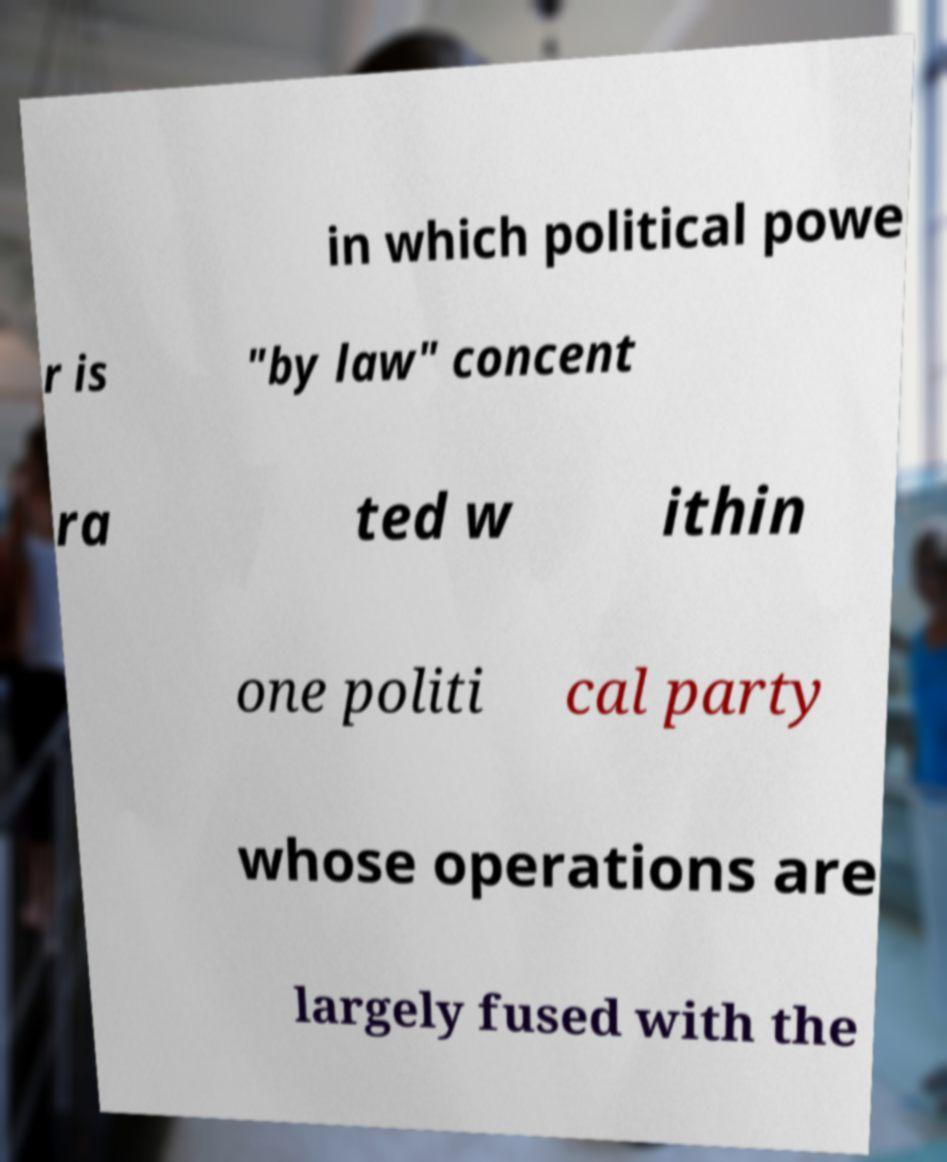What messages or text are displayed in this image? I need them in a readable, typed format. in which political powe r is "by law" concent ra ted w ithin one politi cal party whose operations are largely fused with the 